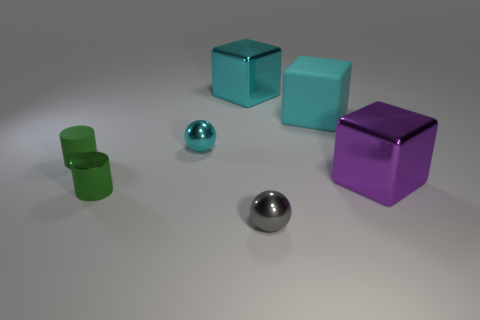Add 1 purple shiny objects. How many objects exist? 8 Subtract all cylinders. How many objects are left? 5 Subtract 0 blue balls. How many objects are left? 7 Subtract all small purple cylinders. Subtract all gray metal things. How many objects are left? 6 Add 3 shiny blocks. How many shiny blocks are left? 5 Add 2 large cyan blocks. How many large cyan blocks exist? 4 